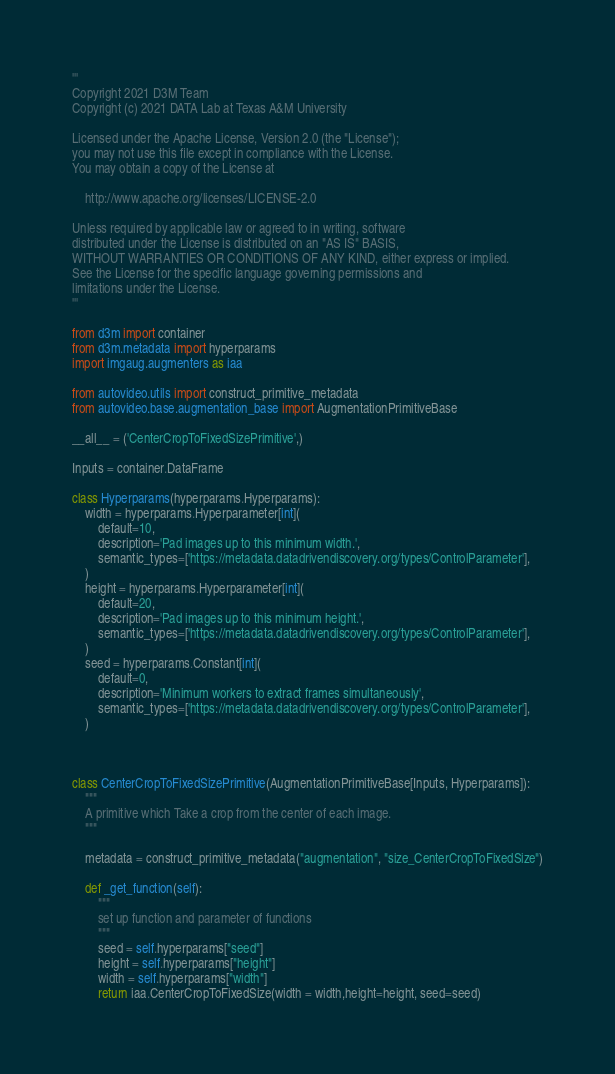<code> <loc_0><loc_0><loc_500><loc_500><_Python_>'''
Copyright 2021 D3M Team
Copyright (c) 2021 DATA Lab at Texas A&M University

Licensed under the Apache License, Version 2.0 (the "License");
you may not use this file except in compliance with the License.
You may obtain a copy of the License at

    http://www.apache.org/licenses/LICENSE-2.0

Unless required by applicable law or agreed to in writing, software
distributed under the License is distributed on an "AS IS" BASIS,
WITHOUT WARRANTIES OR CONDITIONS OF ANY KIND, either express or implied.
See the License for the specific language governing permissions and
limitations under the License.
'''

from d3m import container
from d3m.metadata import hyperparams
import imgaug.augmenters as iaa

from autovideo.utils import construct_primitive_metadata
from autovideo.base.augmentation_base import AugmentationPrimitiveBase

__all__ = ('CenterCropToFixedSizePrimitive',)

Inputs = container.DataFrame

class Hyperparams(hyperparams.Hyperparams):
    width = hyperparams.Hyperparameter[int](
        default=10,
        description='Pad images up to this minimum width.',
        semantic_types=['https://metadata.datadrivendiscovery.org/types/ControlParameter'],
    )
    height = hyperparams.Hyperparameter[int](
        default=20,
        description='Pad images up to this minimum height.',
        semantic_types=['https://metadata.datadrivendiscovery.org/types/ControlParameter'],
    )
    seed = hyperparams.Constant[int](
        default=0,
        description='Minimum workers to extract frames simultaneously',
        semantic_types=['https://metadata.datadrivendiscovery.org/types/ControlParameter'],
    )



class CenterCropToFixedSizePrimitive(AugmentationPrimitiveBase[Inputs, Hyperparams]):
    """
    A primitive which Take a crop from the center of each image.
    """

    metadata = construct_primitive_metadata("augmentation", "size_CenterCropToFixedSize")

    def _get_function(self):
        """
        set up function and parameter of functions
        """
        seed = self.hyperparams["seed"]
        height = self.hyperparams["height"]
        width = self.hyperparams["width"]
        return iaa.CenterCropToFixedSize(width = width,height=height, seed=seed)</code> 